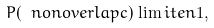<formula> <loc_0><loc_0><loc_500><loc_500>P ( \ n o n o v e r l a p c ) \lim i t e { n } 1 ,</formula> 